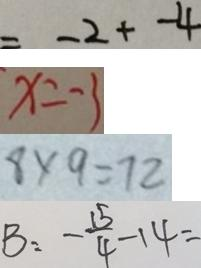<formula> <loc_0><loc_0><loc_500><loc_500>= - 2 + - 4 
 x = - 3 
 8 \times 9 = 7 2 
 B : - \frac { 1 5 } { 4 } - 1 4 =</formula> 